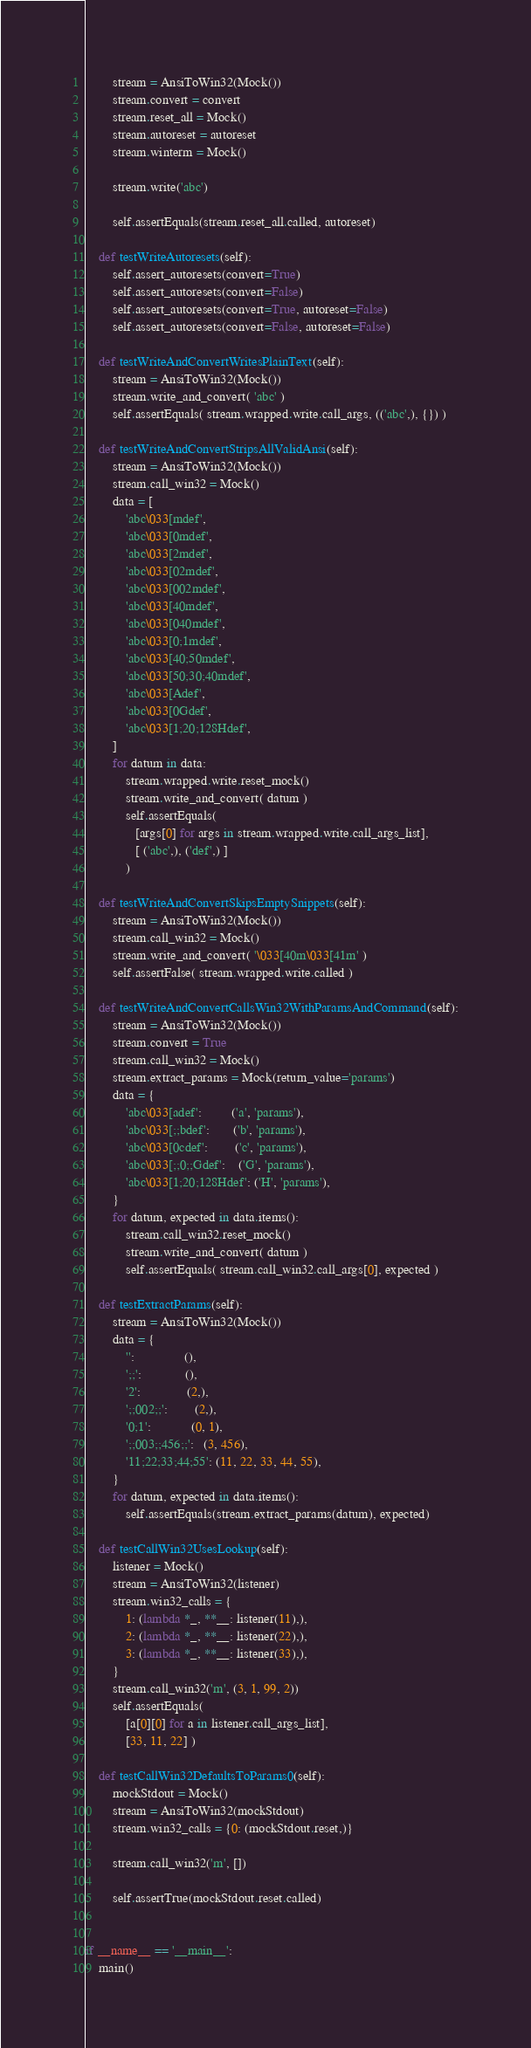Convert code to text. <code><loc_0><loc_0><loc_500><loc_500><_Python_>        stream = AnsiToWin32(Mock())
        stream.convert = convert
        stream.reset_all = Mock()
        stream.autoreset = autoreset
        stream.winterm = Mock()

        stream.write('abc')
        
        self.assertEquals(stream.reset_all.called, autoreset)

    def testWriteAutoresets(self):
        self.assert_autoresets(convert=True)
        self.assert_autoresets(convert=False)
        self.assert_autoresets(convert=True, autoreset=False)
        self.assert_autoresets(convert=False, autoreset=False)

    def testWriteAndConvertWritesPlainText(self):
        stream = AnsiToWin32(Mock())
        stream.write_and_convert( 'abc' )
        self.assertEquals( stream.wrapped.write.call_args, (('abc',), {}) )

    def testWriteAndConvertStripsAllValidAnsi(self):
        stream = AnsiToWin32(Mock())
        stream.call_win32 = Mock()
        data = [
            'abc\033[mdef',
            'abc\033[0mdef',
            'abc\033[2mdef',
            'abc\033[02mdef',
            'abc\033[002mdef',
            'abc\033[40mdef',
            'abc\033[040mdef',
            'abc\033[0;1mdef',
            'abc\033[40;50mdef',
            'abc\033[50;30;40mdef',
            'abc\033[Adef',
            'abc\033[0Gdef',
            'abc\033[1;20;128Hdef',
        ]
        for datum in data:
            stream.wrapped.write.reset_mock()
            stream.write_and_convert( datum )
            self.assertEquals(
               [args[0] for args in stream.wrapped.write.call_args_list],
               [ ('abc',), ('def',) ]
            )

    def testWriteAndConvertSkipsEmptySnippets(self):
        stream = AnsiToWin32(Mock())
        stream.call_win32 = Mock()
        stream.write_and_convert( '\033[40m\033[41m' )
        self.assertFalse( stream.wrapped.write.called )

    def testWriteAndConvertCallsWin32WithParamsAndCommand(self):
        stream = AnsiToWin32(Mock())
        stream.convert = True
        stream.call_win32 = Mock()
        stream.extract_params = Mock(return_value='params')
        data = {
            'abc\033[adef':         ('a', 'params'),
            'abc\033[;;bdef':       ('b', 'params'),
            'abc\033[0cdef':        ('c', 'params'),
            'abc\033[;;0;;Gdef':    ('G', 'params'),
            'abc\033[1;20;128Hdef': ('H', 'params'),
        }
        for datum, expected in data.items():
            stream.call_win32.reset_mock()
            stream.write_and_convert( datum )
            self.assertEquals( stream.call_win32.call_args[0], expected )

    def testExtractParams(self):
        stream = AnsiToWin32(Mock())
        data = {
            '':               (),
            ';;':             (),
            '2':              (2,),
            ';;002;;':        (2,),
            '0;1':            (0, 1),
            ';;003;;456;;':   (3, 456),
            '11;22;33;44;55': (11, 22, 33, 44, 55),
        }
        for datum, expected in data.items():
            self.assertEquals(stream.extract_params(datum), expected)

    def testCallWin32UsesLookup(self):
        listener = Mock()
        stream = AnsiToWin32(listener)
        stream.win32_calls = {
            1: (lambda *_, **__: listener(11),),
            2: (lambda *_, **__: listener(22),),
            3: (lambda *_, **__: listener(33),),
        }
        stream.call_win32('m', (3, 1, 99, 2))
        self.assertEquals(
            [a[0][0] for a in listener.call_args_list],
            [33, 11, 22] )

    def testCallWin32DefaultsToParams0(self):
        mockStdout = Mock()
        stream = AnsiToWin32(mockStdout)
        stream.win32_calls = {0: (mockStdout.reset,)}
        
        stream.call_win32('m', [])

        self.assertTrue(mockStdout.reset.called)


if __name__ == '__main__':
    main()

</code> 